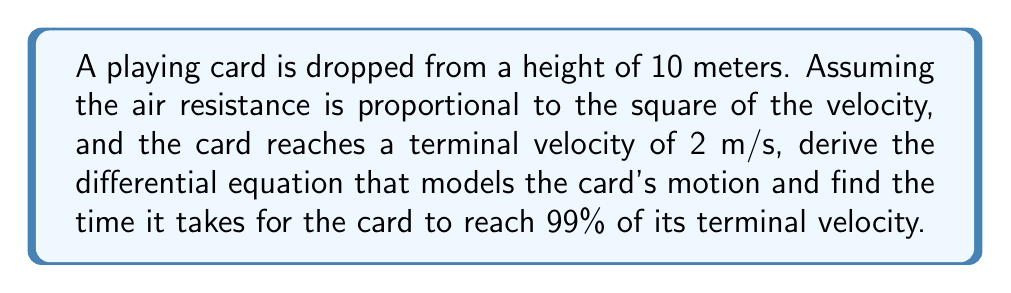Can you answer this question? Let's approach this step-by-step:

1) First, we need to set up our differential equation. Let $y$ be the distance fallen and $v = \frac{dy}{dt}$ be the velocity. The forces acting on the card are gravity and air resistance.

2) The equation of motion is:

   $m\frac{dv}{dt} = mg - kv^2$

   where $m$ is the mass of the card, $g$ is the acceleration due to gravity, and $k$ is the air resistance coefficient.

3) At terminal velocity $v_t$, acceleration is zero:

   $0 = mg - kv_t^2$
   $k = \frac{mg}{v_t^2}$

4) Substituting this back into our original equation:

   $m\frac{dv}{dt} = mg - mg\frac{v^2}{v_t^2}$

5) Dividing both sides by $m$:

   $\frac{dv}{dt} = g(1 - \frac{v^2}{v_t^2})$

6) To solve this, we can separate variables:

   $\frac{dv}{1 - \frac{v^2}{v_t^2}} = g dt$

7) Integrating both sides:

   $-\frac{v_t}{2}\ln(1 - \frac{v^2}{v_t^2}) = gt + C$

8) At $t=0$, $v=0$, so $C=0$. Therefore:

   $v = v_t\tanh(\frac{gt}{v_t})$

9) To find the time to reach 99% of terminal velocity:

   $0.99v_t = v_t\tanh(\frac{gt}{v_t})$
   $0.99 = \tanh(\frac{gt}{v_t})$
   $\tanh^{-1}(0.99) = \frac{gt}{v_t}$

10) Solving for $t$:

    $t = \frac{v_t}{g}\tanh^{-1}(0.99)$

11) Given $v_t = 2$ m/s and $g = 9.8$ m/s^2:

    $t = \frac{2}{9.8}\tanh^{-1}(0.99) \approx 0.5866$ seconds
Answer: $0.5866$ seconds 